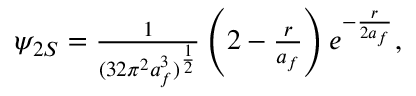Convert formula to latex. <formula><loc_0><loc_0><loc_500><loc_500>\begin{array} { r } { \psi _ { 2 S } = \frac { 1 } { ( 3 2 \pi ^ { 2 } a _ { f } ^ { 3 } ) ^ { \frac { 1 } { 2 } } } \left ( 2 - \frac { r } { a _ { f } } \right ) e ^ { - \frac { r } { 2 a _ { f } } } , } \end{array}</formula> 